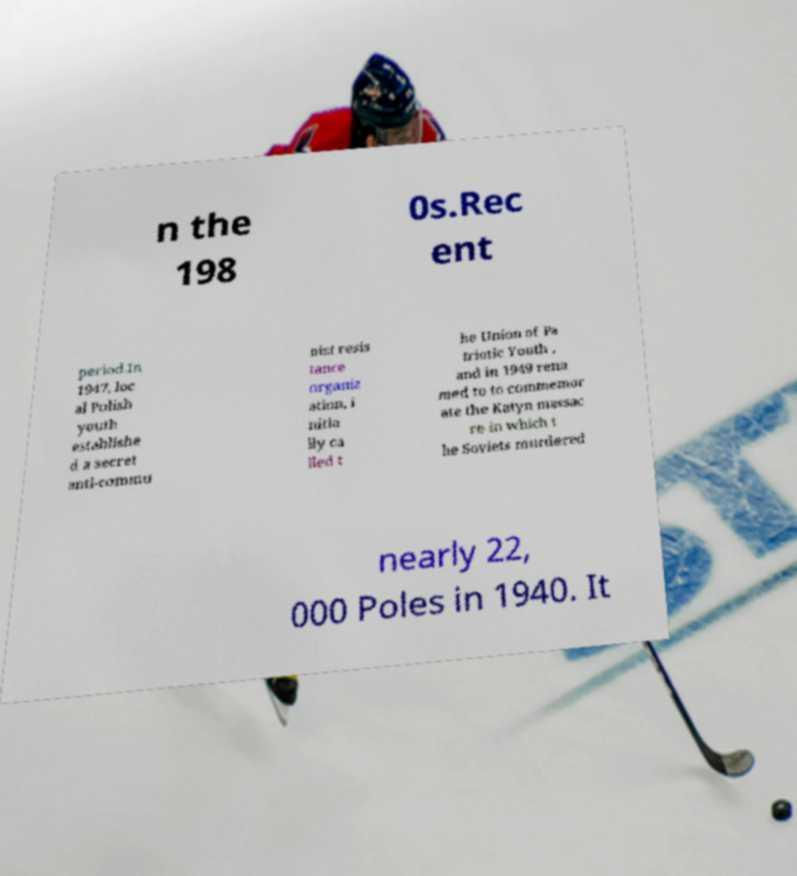Could you extract and type out the text from this image? n the 198 0s.Rec ent period.In 1947, loc al Polish youth establishe d a secret anti-commu nist resis tance organiz ation, i nitia lly ca lled t he Union of Pa triotic Youth , and in 1949 rena med to to commemor ate the Katyn massac re in which t he Soviets murdered nearly 22, 000 Poles in 1940. It 